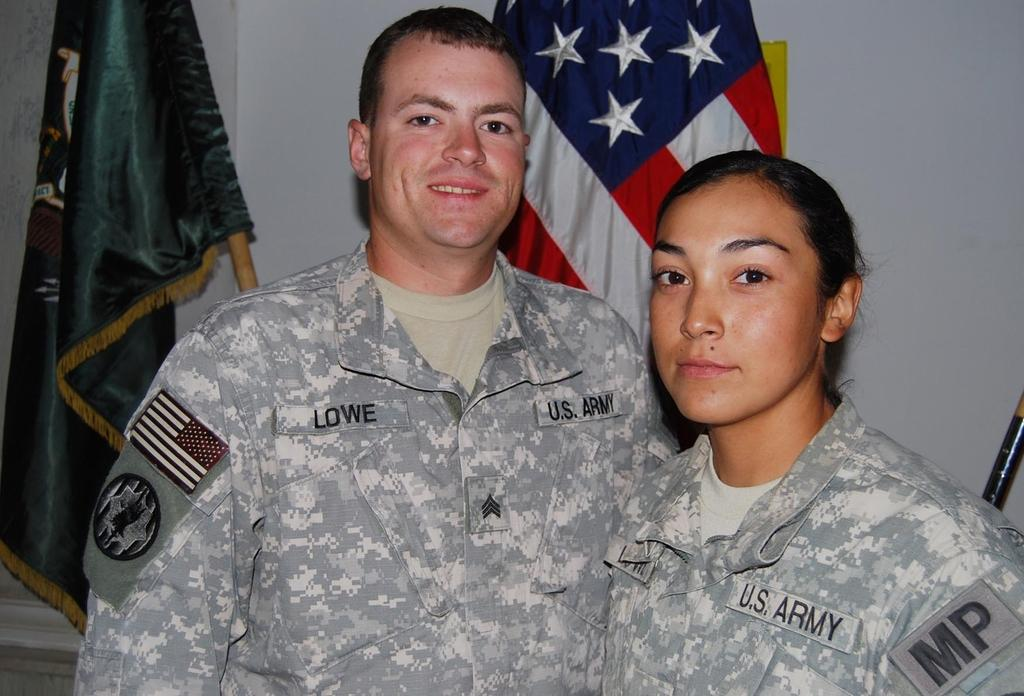How many people are in the image? There are two persons in the image. What are the persons wearing? The persons are wearing uniforms. What can be seen in the image besides the people? There are flags visible in the image. What is in the background of the image? There is a wall in the background of the image. What type of boat can be seen in the image? There is no boat present in the image. What is the texture of the chin of the person on the left? The image does not provide enough detail to determine the texture of the person's chin. 